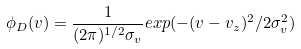Convert formula to latex. <formula><loc_0><loc_0><loc_500><loc_500>\phi _ { D } ( v ) = \frac { 1 } { ( 2 \pi ) ^ { 1 / 2 } \sigma _ { v } } e x p ( - ( v - v _ { z } ) ^ { 2 } / 2 \sigma ^ { 2 } _ { v } )</formula> 